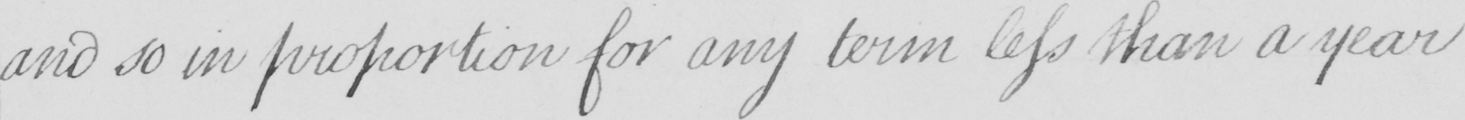Can you tell me what this handwritten text says? and so in proportion for any term less than a year 